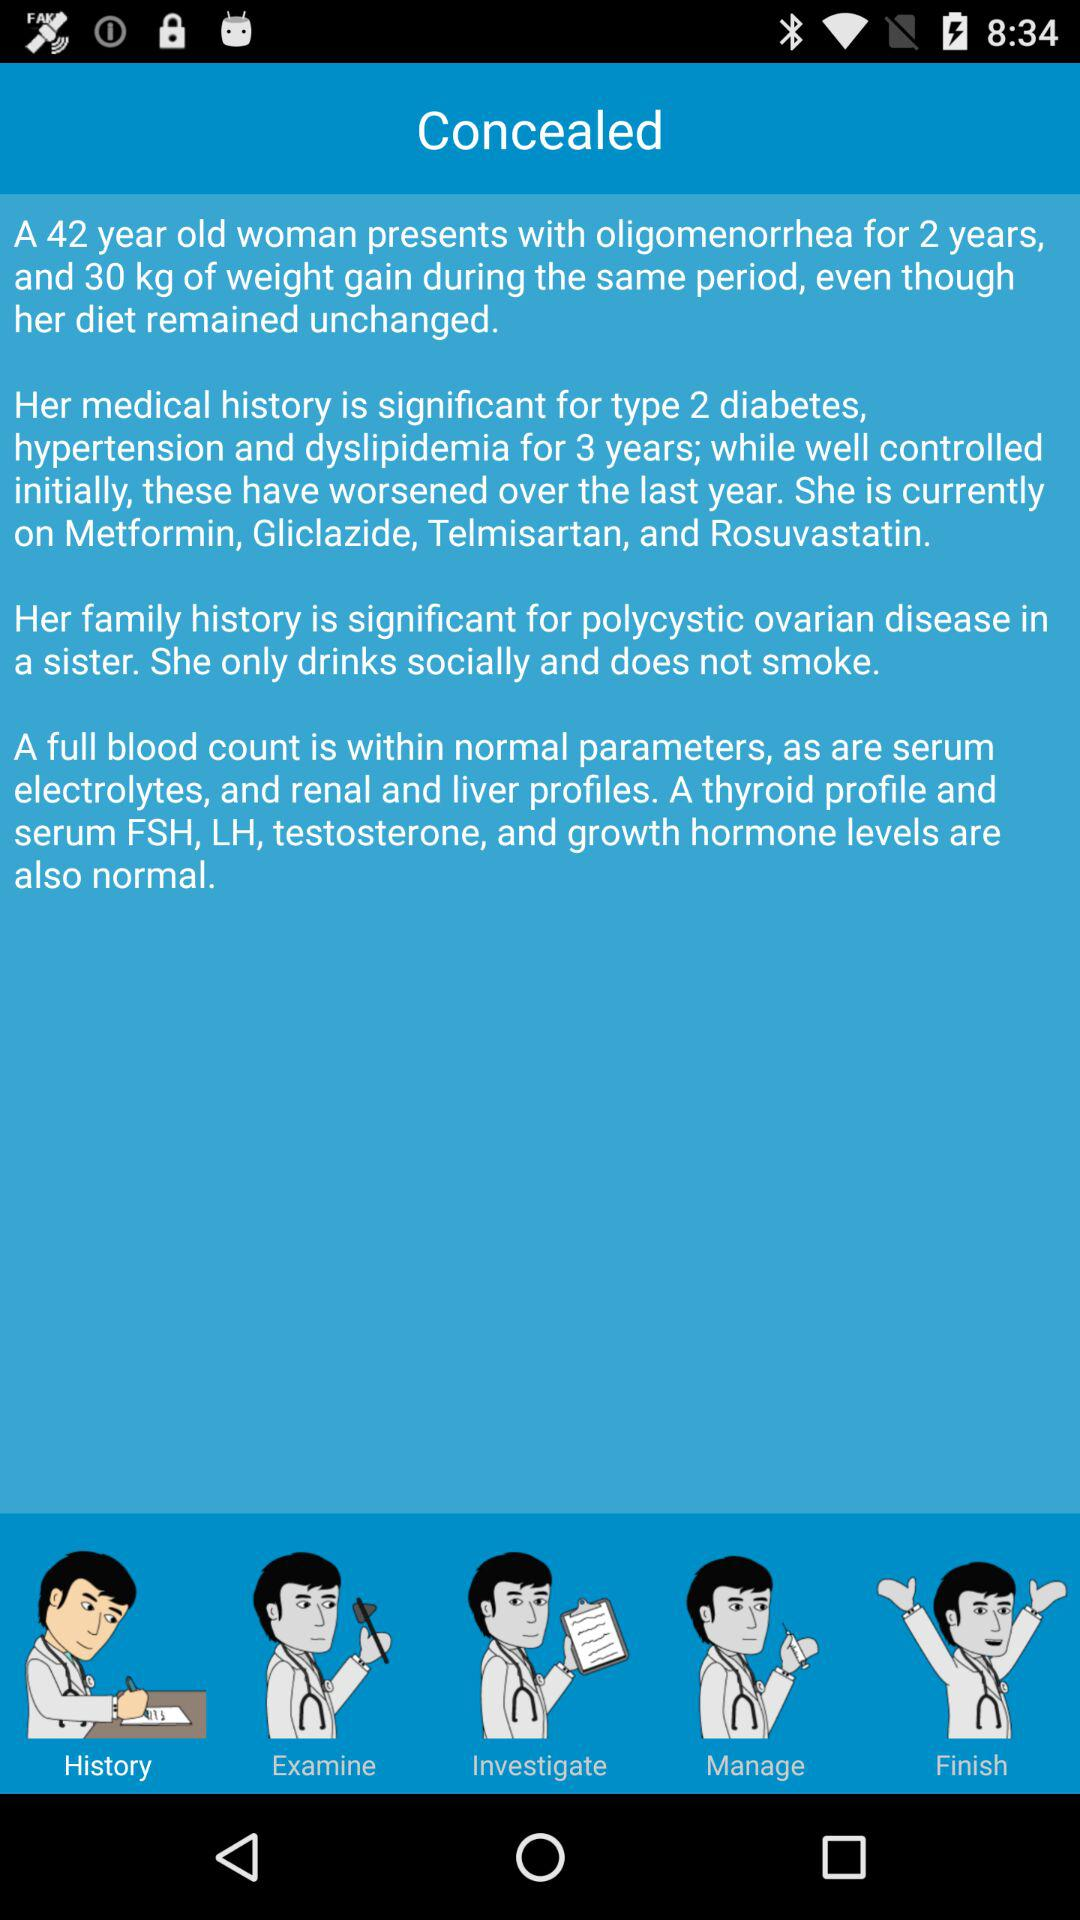How many years has the patient had oligomenorrhea?
Answer the question using a single word or phrase. 2 years 